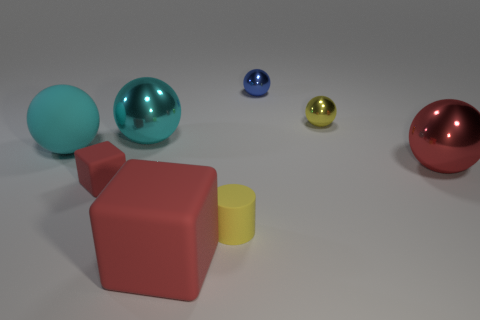Subtract 2 balls. How many balls are left? 3 Subtract all yellow balls. How many balls are left? 4 Subtract all big cyan metal balls. How many balls are left? 4 Subtract all green balls. Subtract all gray cubes. How many balls are left? 5 Add 2 small yellow cylinders. How many objects exist? 10 Subtract all cylinders. How many objects are left? 7 Subtract all red shiny balls. Subtract all yellow shiny objects. How many objects are left? 6 Add 2 red things. How many red things are left? 5 Add 6 big yellow spheres. How many big yellow spheres exist? 6 Subtract 0 brown blocks. How many objects are left? 8 